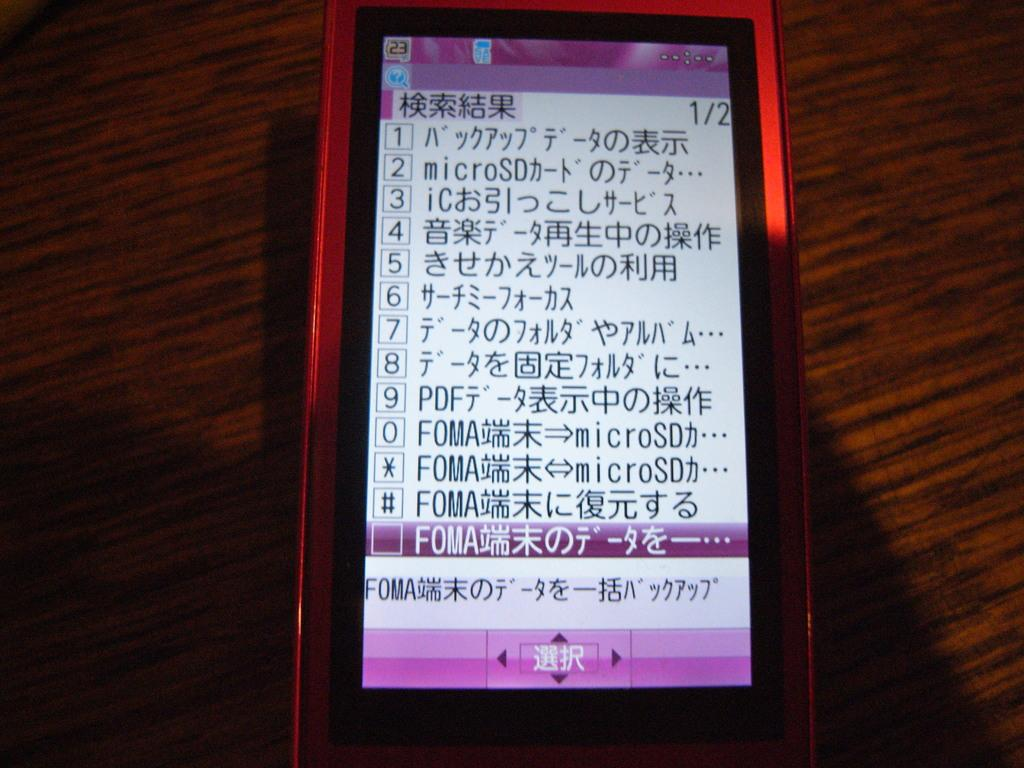<image>
Create a compact narrative representing the image presented. a phone that has the numbers 1-9 on it 